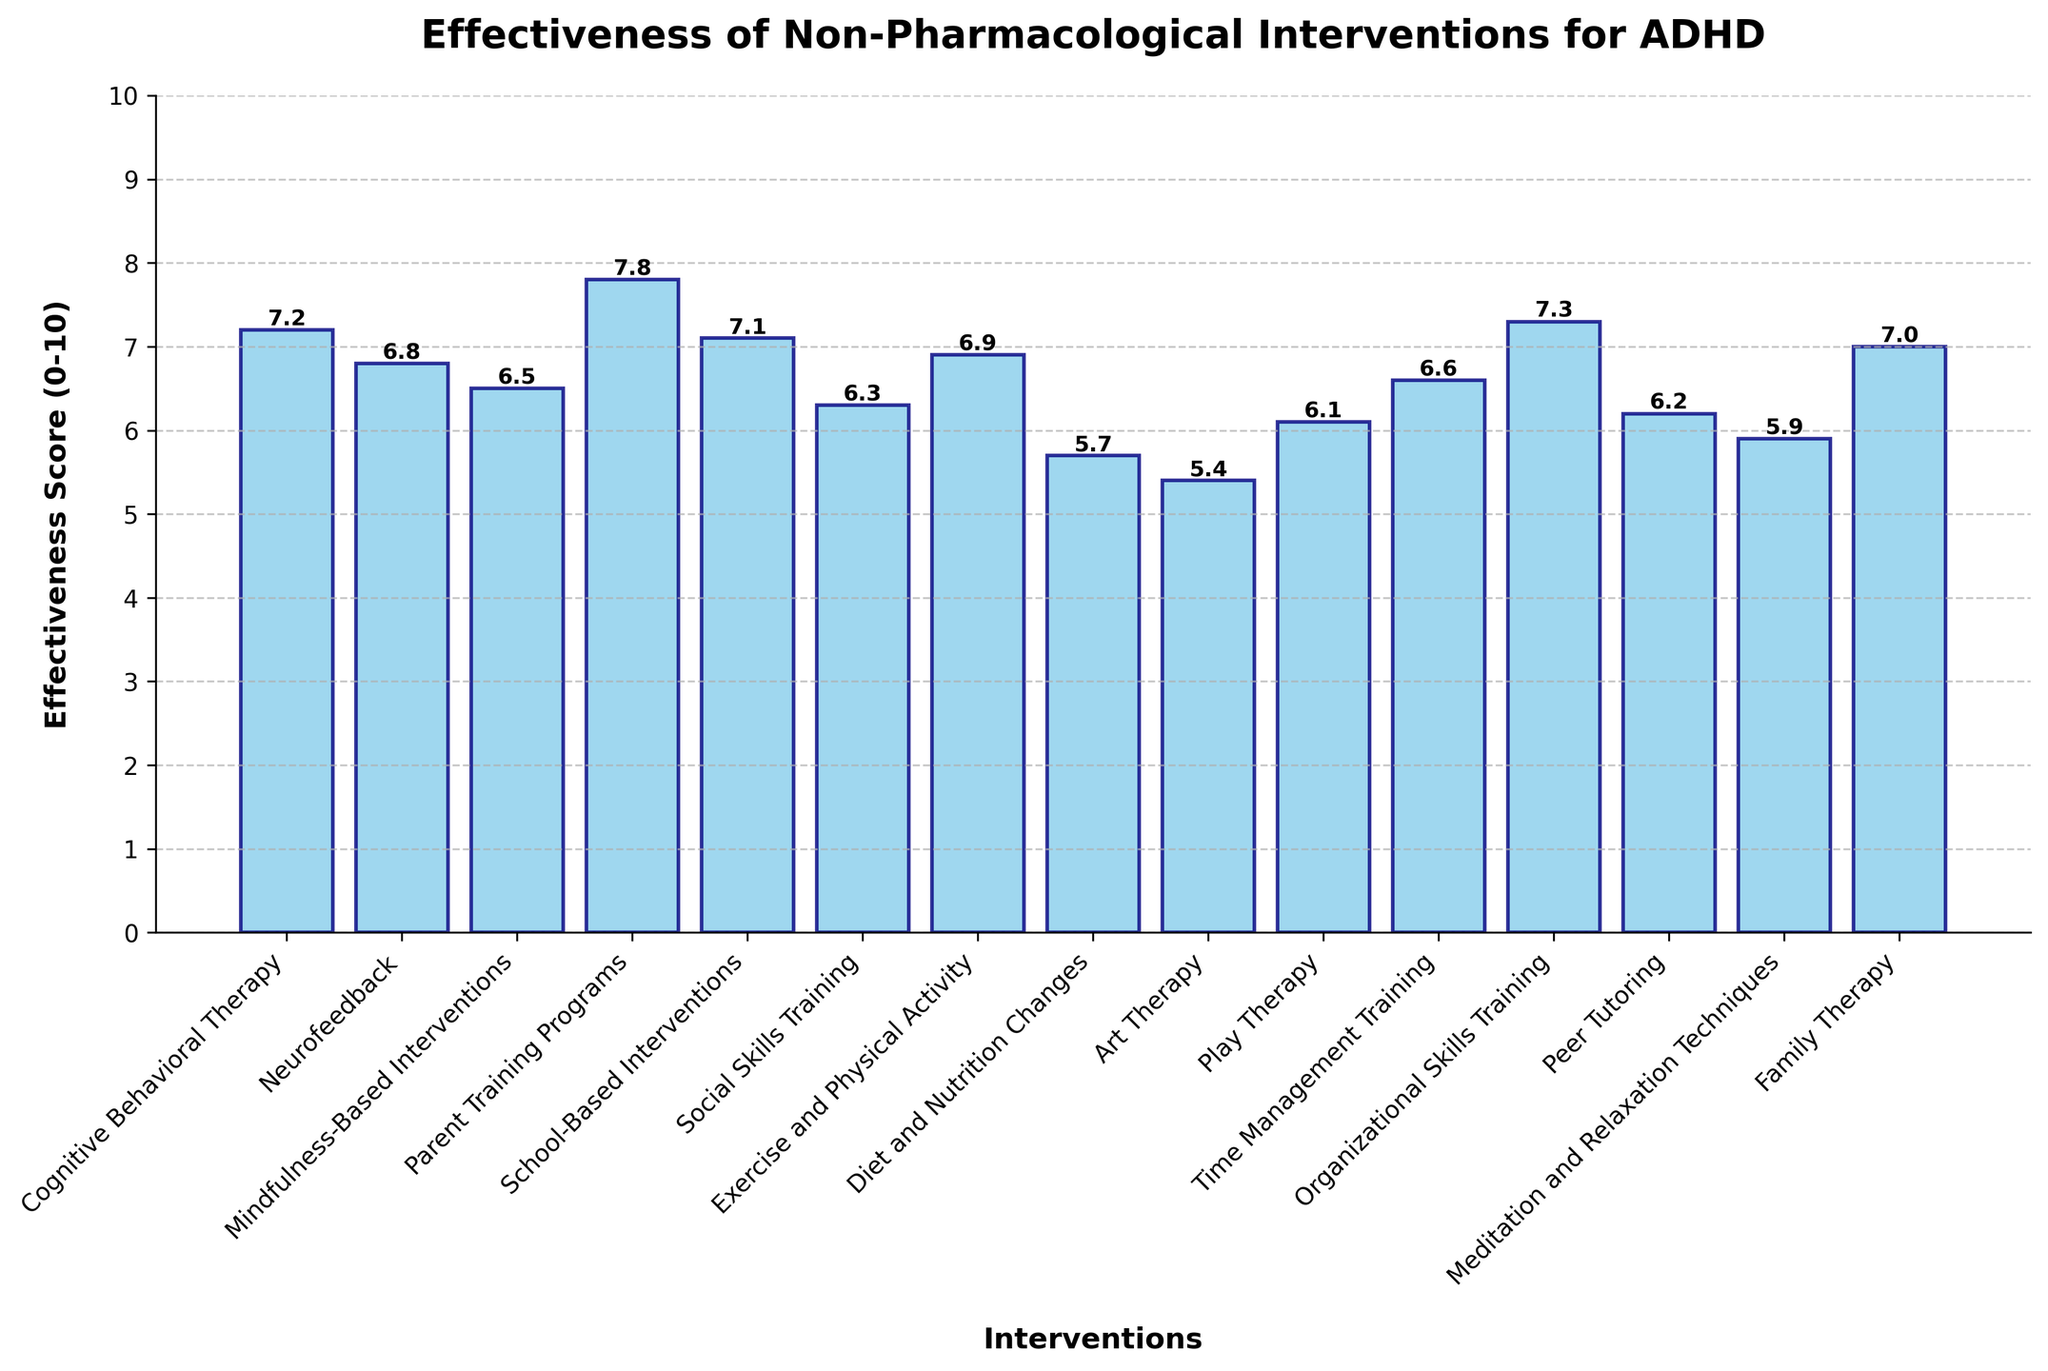Which intervention has the highest effectiveness score? By examining the bar heights, the tallest bar corresponds to Parent Training Programs with a score of 7.8
Answer: Parent Training Programs Which intervention has the lowest effectiveness score? The shortest bar in the chart represents Art Therapy with a score of 5.4
Answer: Art Therapy What is the average effectiveness score of the interventions? Sum all effectiveness scores: 7.2 + 6.8 + 6.5 + 7.8 + 7.1 + 6.3 + 6.9 + 5.7 + 5.4 + 6.1 + 6.6 + 7.3 + 6.2 + 5.9 + 7.0 = 97.8. There are 15 interventions, so the average is 97.8 / 15 = 6.52
Answer: 6.52 How many interventions have an effectiveness score above 7? Interventions with scores above 7 are Cognitive Behavioral Therapy, Parent Training Programs, School-Based Interventions, and Organizational Skills Training. There are 4 such interventions.
Answer: 4 Which intervention is more effective, Neurofeedback or Meditation and Relaxation Techniques? Comparing the bars for Neurofeedback and Meditation and Relaxation Techniques, Neurofeedback has a score of 6.8 while Meditation and Relaxation Techniques have a score of 5.9. Therefore, Neurofeedback is more effective.
Answer: Neurofeedback What is the total effectiveness score of Cognitive Behavioral Therapy, Neurofeedback, and Mindfulness-Based Interventions? Sum the effectiveness scores: 7.2 (Cognitive Behavioral Therapy) + 6.8 (Neurofeedback) + 6.5 (Mindfulness-Based Interventions) = 20.5
Answer: 20.5 Which interventions have scores that are within 1 point of the effectiveness score of Family Therapy? Family Therapy has a score of 7.0. Checking the scores within 1 point (6.0 to 8.0): Cognitive Behavioral Therapy (7.2), Neurofeedback (6.8), Mindfulness-Based Interventions (6.5), Parent Training Programs (7.8), School-Based Interventions (7.1), Exercise and Physical Activity (6.9), Organizational Skills Training (7.3), and Time Management Training (6.6).
Answer: 8 interventions What is the median effectiveness score of all the interventions? Arrange the scores in ascending order: 5.4, 5.7, 5.9, 6.1, 6.2, 6.3, 6.5, 6.6, 6.8, 6.9, 7.0, 7.1, 7.2, 7.3, 7.8. The middle value in this sorted list is 6.6 (i.e., the 8th value).
Answer: 6.6 How much higher is the effectiveness score of Organizational Skills Training compared to Diet and Nutrition Changes? Organizational Skills Training has an effectiveness score of 7.3, and Diet and Nutrition Changes have a score of 5.7. The difference is 7.3 - 5.7 = 1.6
Answer: 1.6 Which intervention is closest in effectiveness to School-Based Interventions? School-Based Interventions have a score of 7.1. The closest scores are Cognitive Behavioral Therapy (7.2) and Family Therapy (7.0), both within 0.1 point difference.
Answer: Cognitive Behavioral Therapy and Family Therapy 